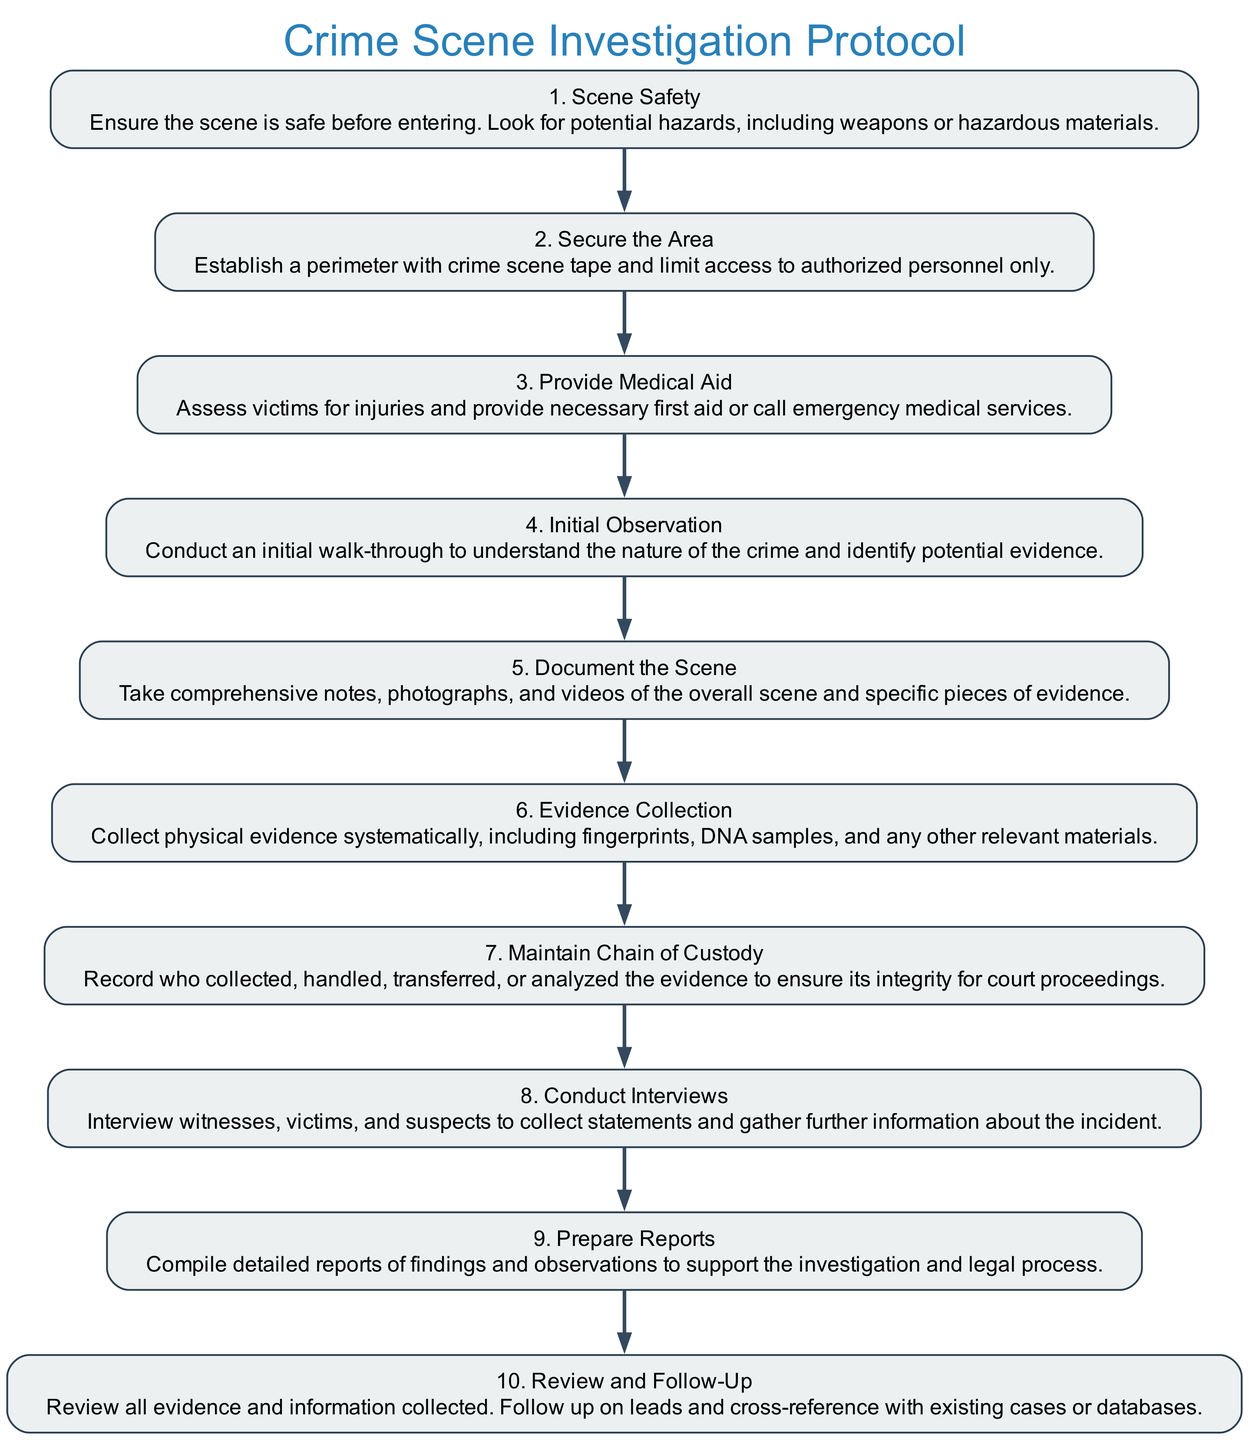What is the first step in the Crime Scene Investigation Protocol? The first step in the diagram is "Scene Safety," which ensures that the area is safe before entering.
Answer: Scene Safety How many total steps are outlined in the Crime Scene Investigation Protocol? By counting the number of nodes in the diagram, we find that there are ten steps outlined in the protocol.
Answer: 10 What is the relationship between "Secure the Area" and "Provide Medical Aid"? "Secure the Area" is the second step, and "Provide Medical Aid" is the third step, indicating that securing the scene takes precedence before assessing medical needs.
Answer: Sequential steps What action is taken immediately after "Initial Observation"? After "Initial Observation," the next step in the protocol is "Document the Scene," which involves taking notes and photographs.
Answer: Document the Scene Which step follows "Maintain Chain of Custody"? The next step after "Maintain Chain of Custody" is "Conduct Interviews," indicating that maintaining the integrity of evidence precedes gathering statements.
Answer: Conduct Interviews How many steps involve directly interacting with victims or witnesses? There are two steps that directly involve interaction with victims or witnesses: "Provide Medical Aid" and "Conduct Interviews."
Answer: 2 What must happen before initiating evidence collection? Before commencing "Evidence Collection," the preceding step is "Document the Scene," which ensures that all evidence is accurately logged as it is collected.
Answer: Document the Scene Which step is focused on legal documentation? The step "Prepare Reports" is specifically focused on compiling detailed written documentation of the investigation findings for legal purposes.
Answer: Prepare Reports In which step is the initial assessment of victims conducted? The initial assessment of victims occurs in the step "Provide Medical Aid," where injuries are assessed and aid is given.
Answer: Provide Medical Aid What is the final step in the Crime Scene Investigation Protocol? The final step in the protocol is "Review and Follow-Up," where all collected evidence is reviewed and further information is sought.
Answer: Review and Follow-Up 